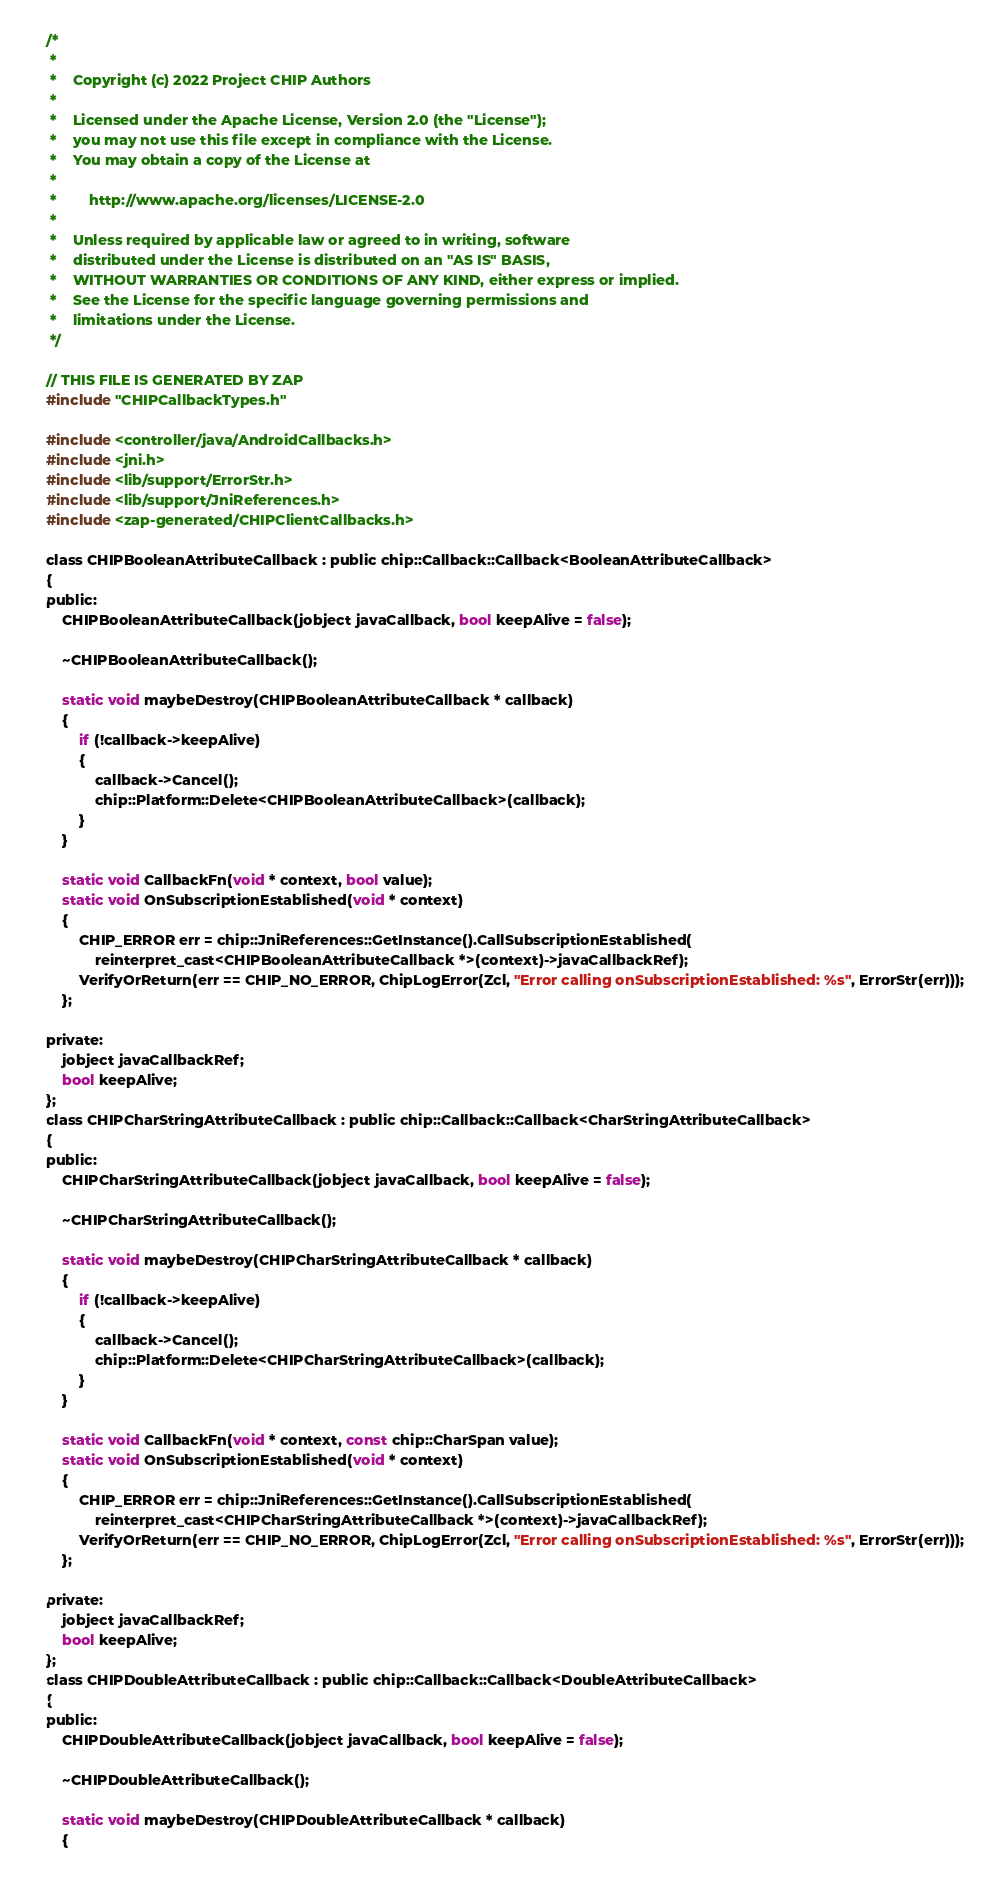<code> <loc_0><loc_0><loc_500><loc_500><_C_>/*
 *
 *    Copyright (c) 2022 Project CHIP Authors
 *
 *    Licensed under the Apache License, Version 2.0 (the "License");
 *    you may not use this file except in compliance with the License.
 *    You may obtain a copy of the License at
 *
 *        http://www.apache.org/licenses/LICENSE-2.0
 *
 *    Unless required by applicable law or agreed to in writing, software
 *    distributed under the License is distributed on an "AS IS" BASIS,
 *    WITHOUT WARRANTIES OR CONDITIONS OF ANY KIND, either express or implied.
 *    See the License for the specific language governing permissions and
 *    limitations under the License.
 */

// THIS FILE IS GENERATED BY ZAP
#include "CHIPCallbackTypes.h"

#include <controller/java/AndroidCallbacks.h>
#include <jni.h>
#include <lib/support/ErrorStr.h>
#include <lib/support/JniReferences.h>
#include <zap-generated/CHIPClientCallbacks.h>

class CHIPBooleanAttributeCallback : public chip::Callback::Callback<BooleanAttributeCallback>
{
public:
    CHIPBooleanAttributeCallback(jobject javaCallback, bool keepAlive = false);

    ~CHIPBooleanAttributeCallback();

    static void maybeDestroy(CHIPBooleanAttributeCallback * callback)
    {
        if (!callback->keepAlive)
        {
            callback->Cancel();
            chip::Platform::Delete<CHIPBooleanAttributeCallback>(callback);
        }
    }

    static void CallbackFn(void * context, bool value);
    static void OnSubscriptionEstablished(void * context)
    {
        CHIP_ERROR err = chip::JniReferences::GetInstance().CallSubscriptionEstablished(
            reinterpret_cast<CHIPBooleanAttributeCallback *>(context)->javaCallbackRef);
        VerifyOrReturn(err == CHIP_NO_ERROR, ChipLogError(Zcl, "Error calling onSubscriptionEstablished: %s", ErrorStr(err)));
    };

private:
    jobject javaCallbackRef;
    bool keepAlive;
};
class CHIPCharStringAttributeCallback : public chip::Callback::Callback<CharStringAttributeCallback>
{
public:
    CHIPCharStringAttributeCallback(jobject javaCallback, bool keepAlive = false);

    ~CHIPCharStringAttributeCallback();

    static void maybeDestroy(CHIPCharStringAttributeCallback * callback)
    {
        if (!callback->keepAlive)
        {
            callback->Cancel();
            chip::Platform::Delete<CHIPCharStringAttributeCallback>(callback);
        }
    }

    static void CallbackFn(void * context, const chip::CharSpan value);
    static void OnSubscriptionEstablished(void * context)
    {
        CHIP_ERROR err = chip::JniReferences::GetInstance().CallSubscriptionEstablished(
            reinterpret_cast<CHIPCharStringAttributeCallback *>(context)->javaCallbackRef);
        VerifyOrReturn(err == CHIP_NO_ERROR, ChipLogError(Zcl, "Error calling onSubscriptionEstablished: %s", ErrorStr(err)));
    };

private:
    jobject javaCallbackRef;
    bool keepAlive;
};
class CHIPDoubleAttributeCallback : public chip::Callback::Callback<DoubleAttributeCallback>
{
public:
    CHIPDoubleAttributeCallback(jobject javaCallback, bool keepAlive = false);

    ~CHIPDoubleAttributeCallback();

    static void maybeDestroy(CHIPDoubleAttributeCallback * callback)
    {</code> 